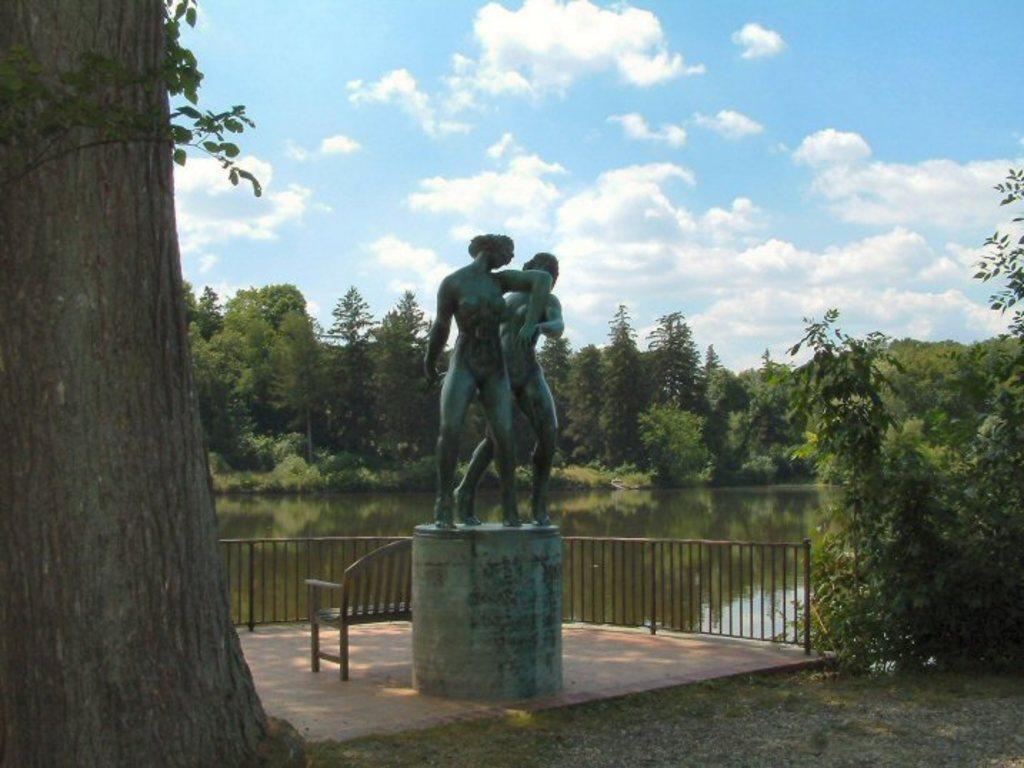Could you give a brief overview of what you see in this image? On the left side, there is a tree on the ground. Beside this tree, there are two statues on a platform. Beside this platform, there is a bench on the floor, which is having a fence. On the right side, there are trees. In the background, there are trees and plants and there are clouds in the sky. 